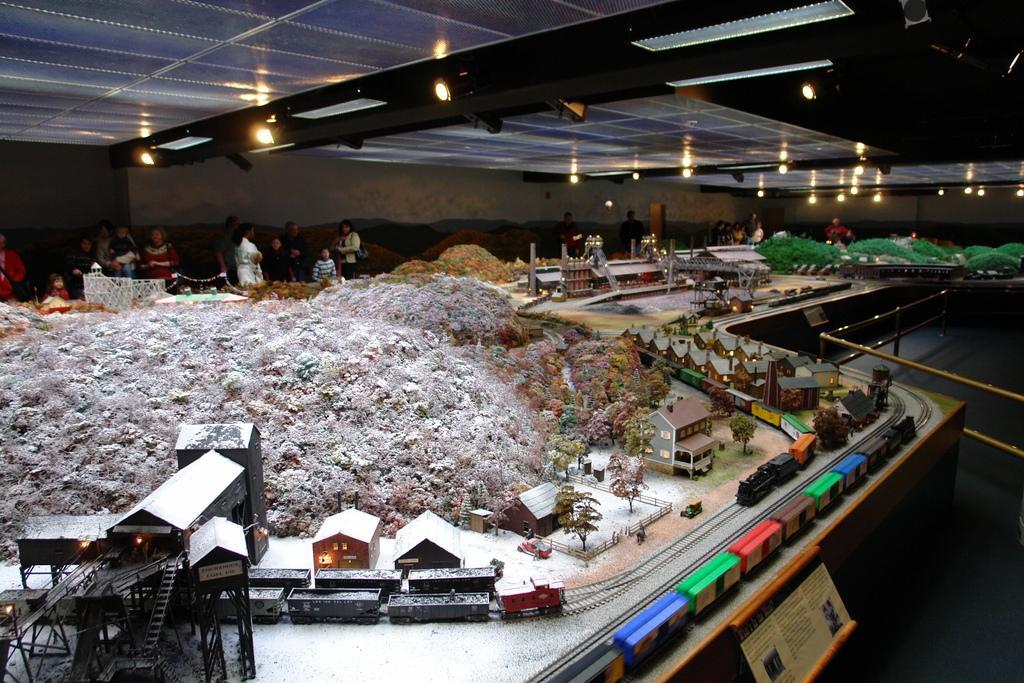Can you describe this image briefly? This is a picture taken in a room. In the foreground of the picture there are toys of houses, railway tracks, trees and many objects. In the background there are people and toys of houses. On the top to the ceiling there are lights. 